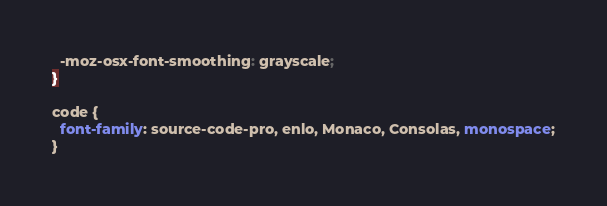Convert code to text. <code><loc_0><loc_0><loc_500><loc_500><_CSS_>  -moz-osx-font-smoothing: grayscale;
}

code {
  font-family: source-code-pro, enlo, Monaco, Consolas, monospace;
}</code> 